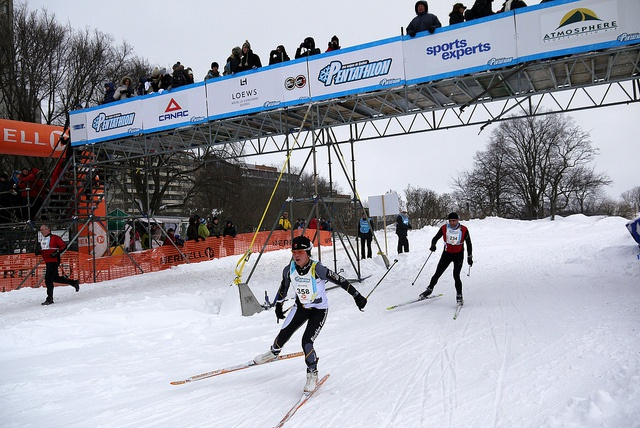Describe the objects in this image and their specific colors. I can see people in black, lightgray, gray, and maroon tones, people in black, lavender, darkgray, and gray tones, people in black, lightgray, maroon, and gray tones, people in black, maroon, gray, and darkgray tones, and skis in black, lightgray, darkgray, brown, and tan tones in this image. 